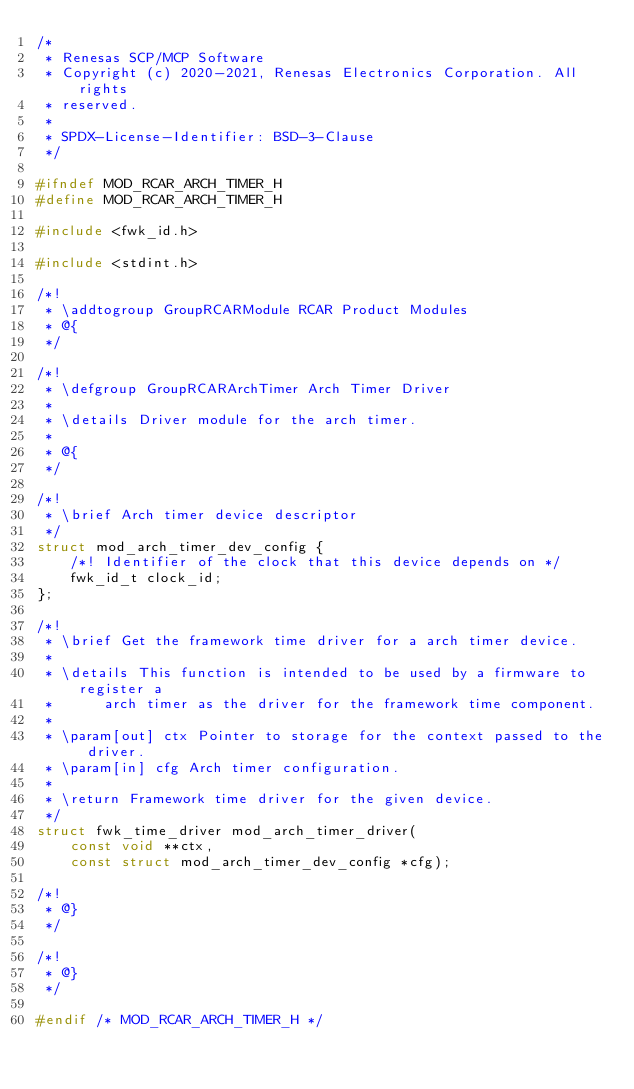Convert code to text. <code><loc_0><loc_0><loc_500><loc_500><_C_>/*
 * Renesas SCP/MCP Software
 * Copyright (c) 2020-2021, Renesas Electronics Corporation. All rights
 * reserved.
 *
 * SPDX-License-Identifier: BSD-3-Clause
 */

#ifndef MOD_RCAR_ARCH_TIMER_H
#define MOD_RCAR_ARCH_TIMER_H

#include <fwk_id.h>

#include <stdint.h>

/*!
 * \addtogroup GroupRCARModule RCAR Product Modules
 * @{
 */

/*!
 * \defgroup GroupRCARArchTimer Arch Timer Driver
 *
 * \details Driver module for the arch timer.
 *
 * @{
 */

/*!
 * \brief Arch timer device descriptor
 */
struct mod_arch_timer_dev_config {
    /*! Identifier of the clock that this device depends on */
    fwk_id_t clock_id;
};

/*!
 * \brief Get the framework time driver for a arch timer device.
 *
 * \details This function is intended to be used by a firmware to register a
 *      arch timer as the driver for the framework time component.
 *
 * \param[out] ctx Pointer to storage for the context passed to the driver.
 * \param[in] cfg Arch timer configuration.
 *
 * \return Framework time driver for the given device.
 */
struct fwk_time_driver mod_arch_timer_driver(
    const void **ctx,
    const struct mod_arch_timer_dev_config *cfg);

/*!
 * @}
 */

/*!
 * @}
 */

#endif /* MOD_RCAR_ARCH_TIMER_H */
</code> 